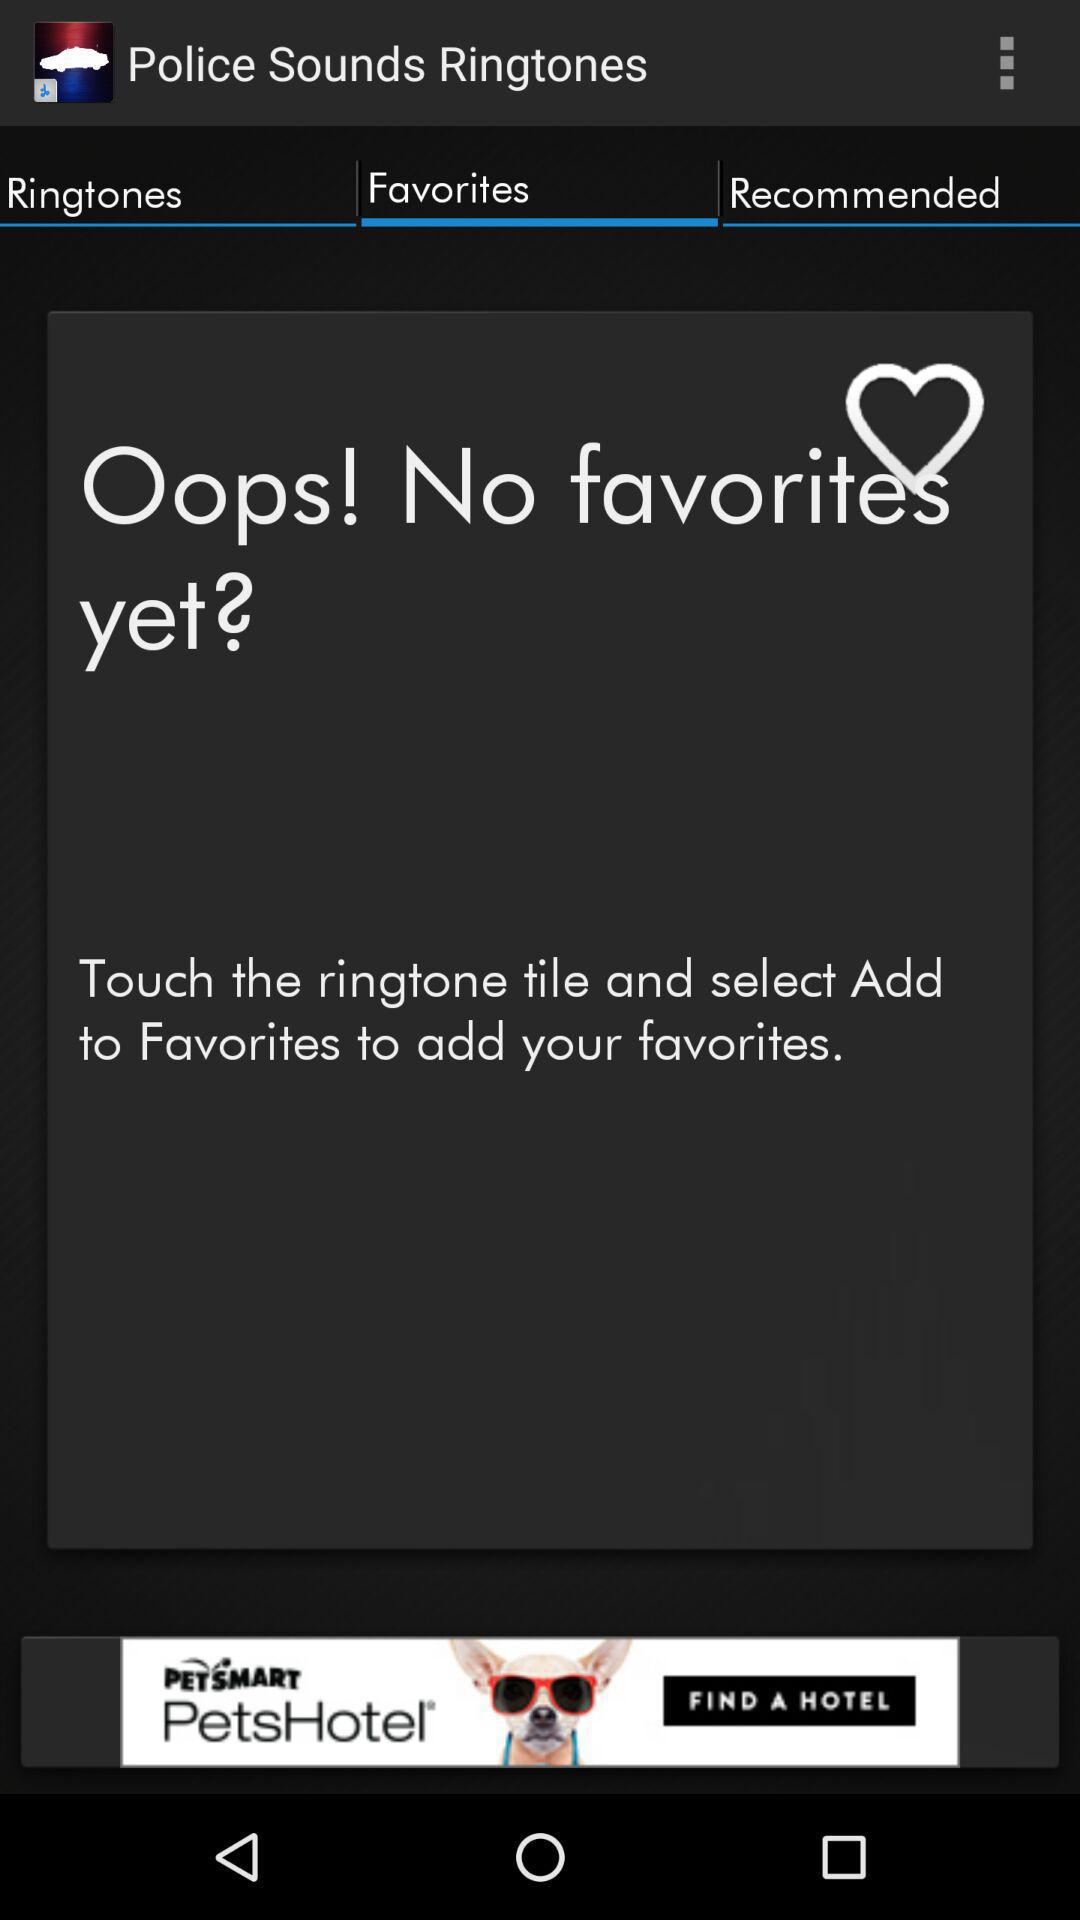How can "Favorites" music be added? The "Favorites" music can be added by touching the "Ringtone" tile and selecting Add to "Favorites". 